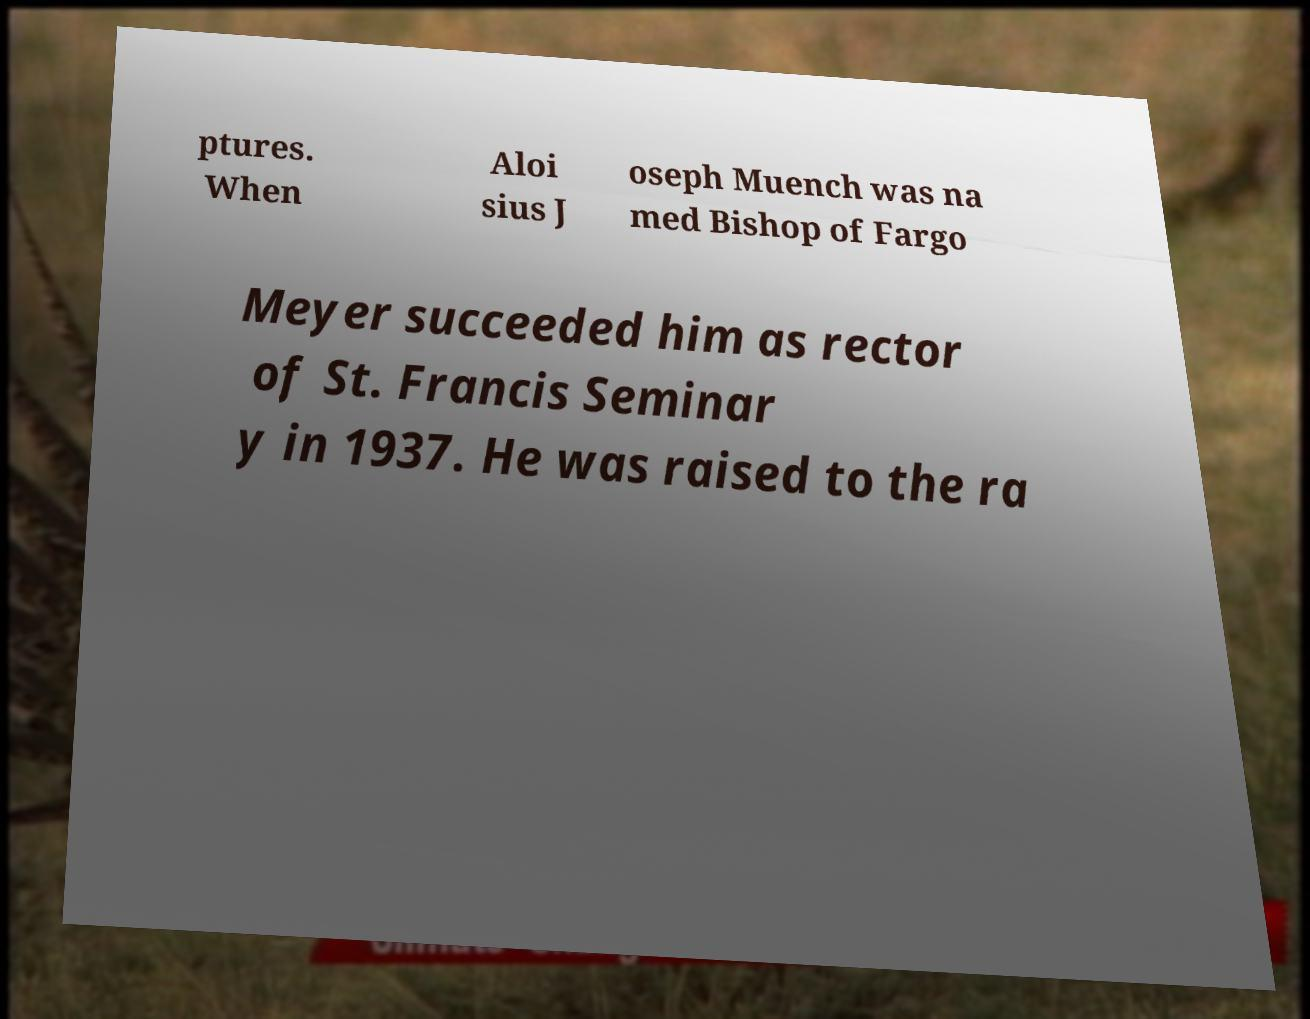Please read and relay the text visible in this image. What does it say? ptures. When Aloi sius J oseph Muench was na med Bishop of Fargo Meyer succeeded him as rector of St. Francis Seminar y in 1937. He was raised to the ra 